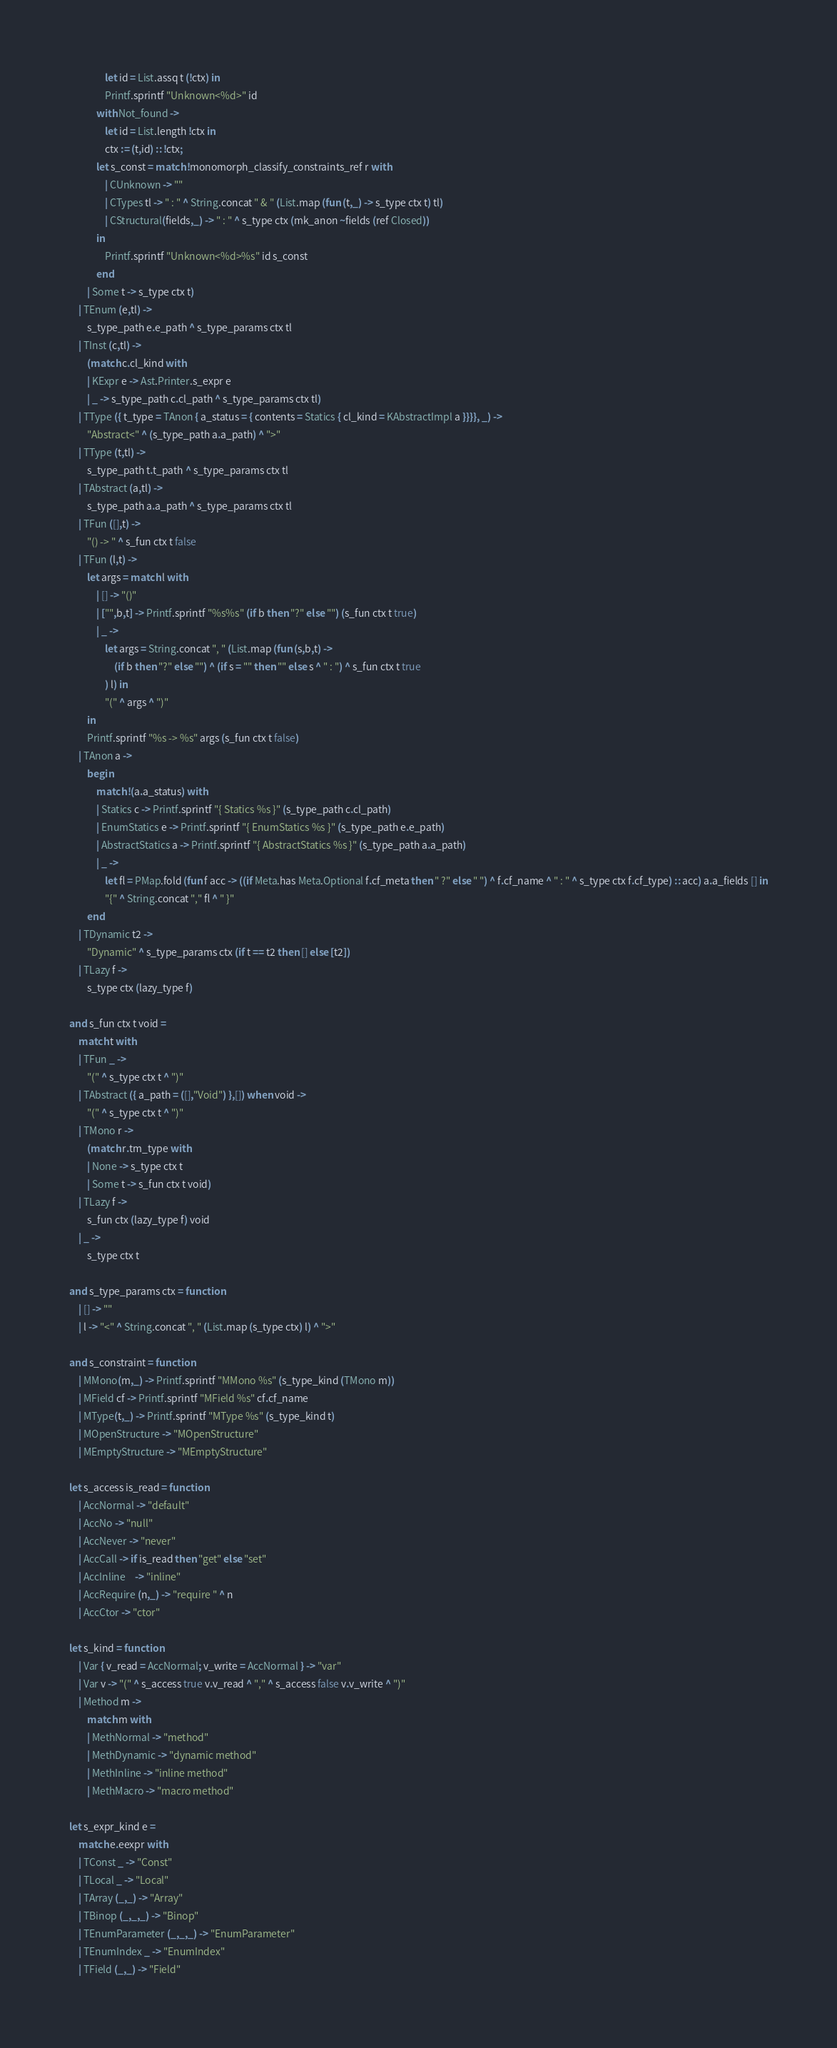<code> <loc_0><loc_0><loc_500><loc_500><_OCaml_>				let id = List.assq t (!ctx) in
				Printf.sprintf "Unknown<%d>" id
			with Not_found ->
				let id = List.length !ctx in
				ctx := (t,id) :: !ctx;
			let s_const = match !monomorph_classify_constraints_ref r with
				| CUnknown -> ""
				| CTypes tl -> " : " ^ String.concat " & " (List.map (fun (t,_) -> s_type ctx t) tl)
				| CStructural(fields,_) -> " : " ^ s_type ctx (mk_anon ~fields (ref Closed))
			in
				Printf.sprintf "Unknown<%d>%s" id s_const
			end
		| Some t -> s_type ctx t)
	| TEnum (e,tl) ->
		s_type_path e.e_path ^ s_type_params ctx tl
	| TInst (c,tl) ->
		(match c.cl_kind with
		| KExpr e -> Ast.Printer.s_expr e
		| _ -> s_type_path c.cl_path ^ s_type_params ctx tl)
	| TType ({ t_type = TAnon { a_status = { contents = Statics { cl_kind = KAbstractImpl a }}}}, _) ->
		"Abstract<" ^ (s_type_path a.a_path) ^ ">"
	| TType (t,tl) ->
		s_type_path t.t_path ^ s_type_params ctx tl
	| TAbstract (a,tl) ->
		s_type_path a.a_path ^ s_type_params ctx tl
	| TFun ([],t) ->
		"() -> " ^ s_fun ctx t false
	| TFun (l,t) ->
		let args = match l with
			| [] -> "()"
			| ["",b,t] -> Printf.sprintf "%s%s" (if b then "?" else "") (s_fun ctx t true)
			| _ ->
				let args = String.concat ", " (List.map (fun (s,b,t) ->
					(if b then "?" else "") ^ (if s = "" then "" else s ^ " : ") ^ s_fun ctx t true
				) l) in
				"(" ^ args ^ ")"
		in
		Printf.sprintf "%s -> %s" args (s_fun ctx t false)
	| TAnon a ->
		begin
			match !(a.a_status) with
			| Statics c -> Printf.sprintf "{ Statics %s }" (s_type_path c.cl_path)
			| EnumStatics e -> Printf.sprintf "{ EnumStatics %s }" (s_type_path e.e_path)
			| AbstractStatics a -> Printf.sprintf "{ AbstractStatics %s }" (s_type_path a.a_path)
			| _ ->
				let fl = PMap.fold (fun f acc -> ((if Meta.has Meta.Optional f.cf_meta then " ?" else " ") ^ f.cf_name ^ " : " ^ s_type ctx f.cf_type) :: acc) a.a_fields [] in
				"{" ^ String.concat "," fl ^ " }"
		end
	| TDynamic t2 ->
		"Dynamic" ^ s_type_params ctx (if t == t2 then [] else [t2])
	| TLazy f ->
		s_type ctx (lazy_type f)

and s_fun ctx t void =
	match t with
	| TFun _ ->
		"(" ^ s_type ctx t ^ ")"
	| TAbstract ({ a_path = ([],"Void") },[]) when void ->
		"(" ^ s_type ctx t ^ ")"
	| TMono r ->
		(match r.tm_type with
		| None -> s_type ctx t
		| Some t -> s_fun ctx t void)
	| TLazy f ->
		s_fun ctx (lazy_type f) void
	| _ ->
		s_type ctx t

and s_type_params ctx = function
	| [] -> ""
	| l -> "<" ^ String.concat ", " (List.map (s_type ctx) l) ^ ">"

and s_constraint = function
	| MMono(m,_) -> Printf.sprintf "MMono %s" (s_type_kind (TMono m))
	| MField cf -> Printf.sprintf "MField %s" cf.cf_name
	| MType(t,_) -> Printf.sprintf "MType %s" (s_type_kind t)
	| MOpenStructure -> "MOpenStructure"
	| MEmptyStructure -> "MEmptyStructure"

let s_access is_read = function
	| AccNormal -> "default"
	| AccNo -> "null"
	| AccNever -> "never"
	| AccCall -> if is_read then "get" else "set"
	| AccInline	-> "inline"
	| AccRequire (n,_) -> "require " ^ n
	| AccCtor -> "ctor"

let s_kind = function
	| Var { v_read = AccNormal; v_write = AccNormal } -> "var"
	| Var v -> "(" ^ s_access true v.v_read ^ "," ^ s_access false v.v_write ^ ")"
	| Method m ->
		match m with
		| MethNormal -> "method"
		| MethDynamic -> "dynamic method"
		| MethInline -> "inline method"
		| MethMacro -> "macro method"

let s_expr_kind e =
	match e.eexpr with
	| TConst _ -> "Const"
	| TLocal _ -> "Local"
	| TArray (_,_) -> "Array"
	| TBinop (_,_,_) -> "Binop"
	| TEnumParameter (_,_,_) -> "EnumParameter"
	| TEnumIndex _ -> "EnumIndex"
	| TField (_,_) -> "Field"</code> 